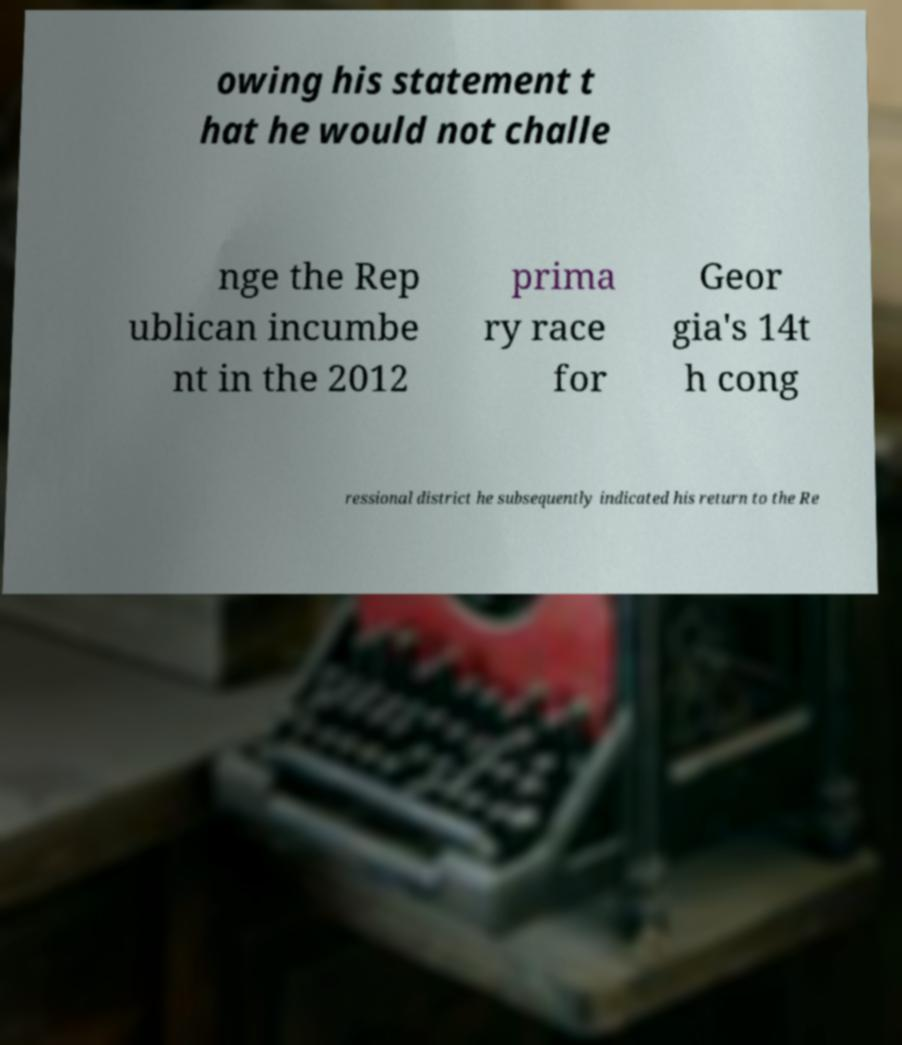For documentation purposes, I need the text within this image transcribed. Could you provide that? owing his statement t hat he would not challe nge the Rep ublican incumbe nt in the 2012 prima ry race for Geor gia's 14t h cong ressional district he subsequently indicated his return to the Re 